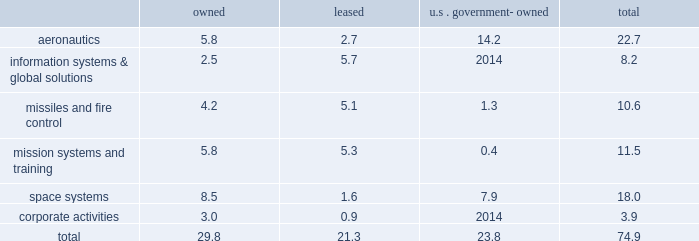Reporting unit 2019s related goodwill assets .
In 2013 , we recorded a non-cash goodwill impairment charge of $ 195 million , net of state tax benefits .
See 201ccritical accounting policies - goodwill 201d in management 2019s discussion and analysis of financial condition and results of operations and 201cnote 1 2013 significant accounting policies 201d for more information on this impairment charge .
Changes in u.s .
Or foreign tax laws , including possibly with retroactive effect , and audits by tax authorities could result in unanticipated increases in our tax expense and affect profitability and cash flows .
For example , proposals to lower the u.s .
Corporate income tax rate would require us to reduce our net deferred tax assets upon enactment of the related tax legislation , with a corresponding material , one-time increase to income tax expense , but our income tax expense and payments would be materially reduced in subsequent years .
Actual financial results could differ from our judgments and estimates .
Refer to 201ccritical accounting policies 201d in management 2019s discussion and analysis of financial condition and results of operations , and 201cnote 1 2013 significant accounting policies 201d of our consolidated financial statements for a complete discussion of our significant accounting policies and use of estimates .
Item 1b .
Unresolved staff comments .
Item 2 .
Properties .
At december 31 , 2013 , we owned or leased building space ( including offices , manufacturing plants , warehouses , service centers , laboratories , and other facilities ) at 518 locations primarily in the u.s .
Additionally , we manage or occupy various u.s .
Government-owned facilities under lease and other arrangements .
At december 31 , 2013 , we had significant operations in the following locations : 2022 aeronautics 2013 palmdale , california ; marietta , georgia ; greenville , south carolina ; fort worth and san antonio , texas ; and montreal , canada .
2022 information systems & global solutions 2013 goodyear , arizona ; sunnyvale , california ; colorado springs and denver , colorado ; gaithersburg and rockville , maryland ; valley forge , pennsylvania ; and houston , texas .
2022 missiles and fire control 2013 camden , arkansas ; orlando , florida ; lexington , kentucky ; and grand prairie , texas .
2022 mission systems and training 2013 orlando , florida ; baltimore , maryland ; moorestown/mt .
Laurel , new jersey ; owego and syracuse , new york ; akron , ohio ; and manassas , virginia .
2022 space systems 2013 huntsville , alabama ; sunnyvale , california ; denver , colorado ; albuquerque , new mexico ; and newtown , pennsylvania .
2022 corporate activities 2013 lakeland , florida and bethesda , maryland .
In november 2013 , we committed to a plan to vacate our leased facilities in goodyear , arizona and akron , ohio , and close our owned facility in newtown , pennsylvania and certain owned buildings at our sunnyvale , california facility .
We expect these closures , which include approximately 2.5 million square feet of facility space , will be substantially complete by the middle of 2015 .
For information regarding these matters , see 201cnote 2 2013 restructuring charges 201d of our consolidated financial statements .
The following is a summary of our square feet of floor space by business segment at december 31 , 2013 , inclusive of the facilities that we plan to vacate as mentioned above ( in millions ) : owned leased u.s .
Government- owned total .
We believe our facilities are in good condition and adequate for their current use .
We may improve , replace , or reduce facilities as considered appropriate to meet the needs of our operations. .
What percentage of total square feet of floor space by business segment at december 31 , 2013 is in missiles and fire control? 
Computations: (10.6 / 74.9)
Answer: 0.14152. 